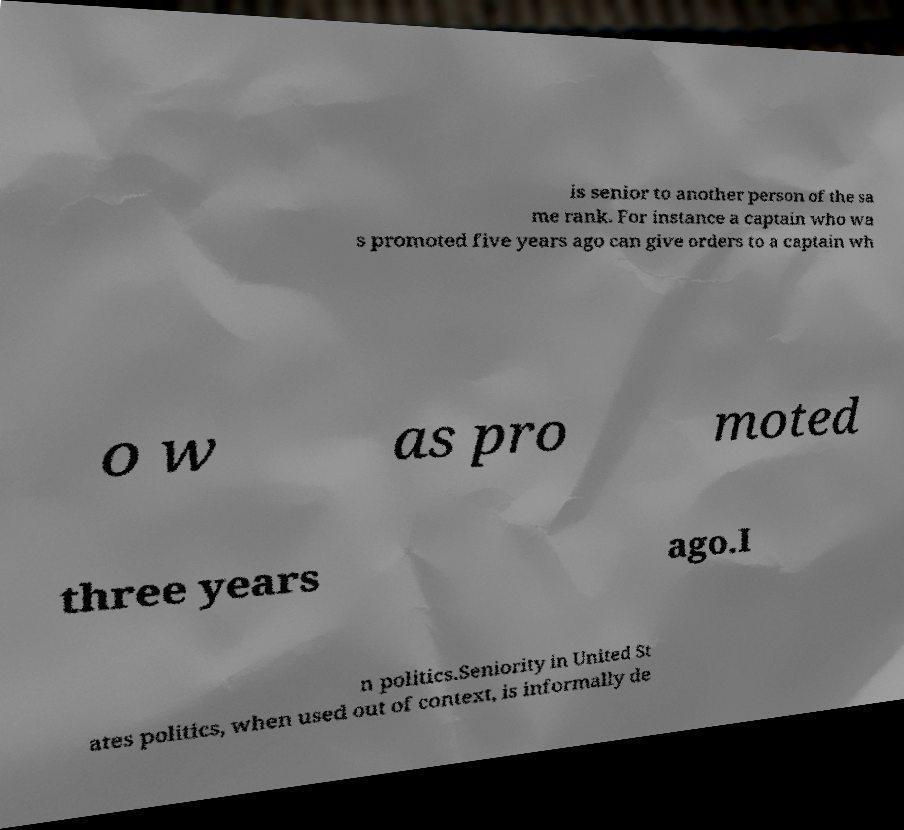Can you read and provide the text displayed in the image?This photo seems to have some interesting text. Can you extract and type it out for me? is senior to another person of the sa me rank. For instance a captain who wa s promoted five years ago can give orders to a captain wh o w as pro moted three years ago.I n politics.Seniority in United St ates politics, when used out of context, is informally de 